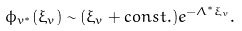<formula> <loc_0><loc_0><loc_500><loc_500>\phi _ { v ^ { * } } ( \xi _ { v } ) \sim ( \xi _ { v } + c o n s t . ) e ^ { - \Lambda ^ { * } \xi _ { v } } .</formula> 